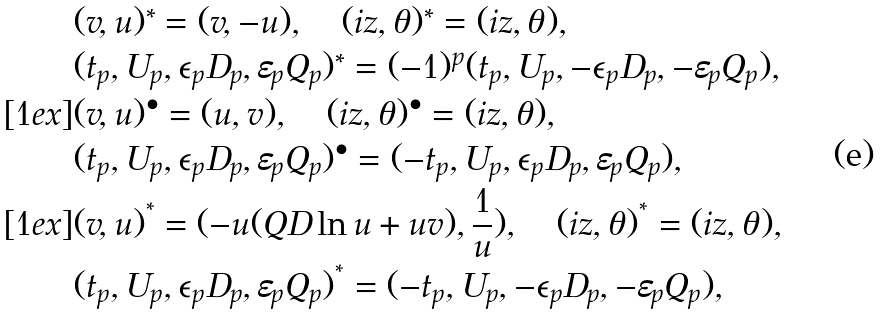Convert formula to latex. <formula><loc_0><loc_0><loc_500><loc_500>& ( v , u ) ^ { * } = ( v , - u ) , \quad ( i z , { \theta } ) ^ { * } = ( i z , { \theta } ) , \\ & ( t _ { p } , U _ { p } , { \epsilon } _ { p } D _ { p } , { \varepsilon } _ { p } Q _ { p } ) ^ { * } = ( - 1 ) ^ { p } ( t _ { p } , U _ { p } , - { \epsilon } _ { p } D _ { p } , - { \varepsilon } _ { p } Q _ { p } ) , \\ [ 1 e x ] & ( v , u ) ^ { \bullet } = ( u , v ) , \quad ( i z , { \theta } ) ^ { \bullet } = ( i z , { \theta } ) , \\ & ( t _ { p } , U _ { p } , { \epsilon } _ { p } D _ { p } , { \varepsilon } _ { p } Q _ { p } ) ^ { \bullet } = ( - t _ { p } , U _ { p } , { \epsilon } _ { p } D _ { p } , { \varepsilon } _ { p } Q _ { p } ) , \\ [ 1 e x ] & ( v , u ) ^ { ^ { * } } = ( - u ( Q D \ln u + u v ) , \frac { 1 } { u } ) , \quad ( i z , { \theta } ) ^ { ^ { * } } = ( i z , { \theta } ) , \\ & ( t _ { p } , U _ { p } , { \epsilon } _ { p } D _ { p } , { \varepsilon } _ { p } Q _ { p } ) ^ { ^ { * } } = ( - t _ { p } , U _ { p } , - { \epsilon } _ { p } D _ { p } , - { \varepsilon } _ { p } Q _ { p } ) ,</formula> 